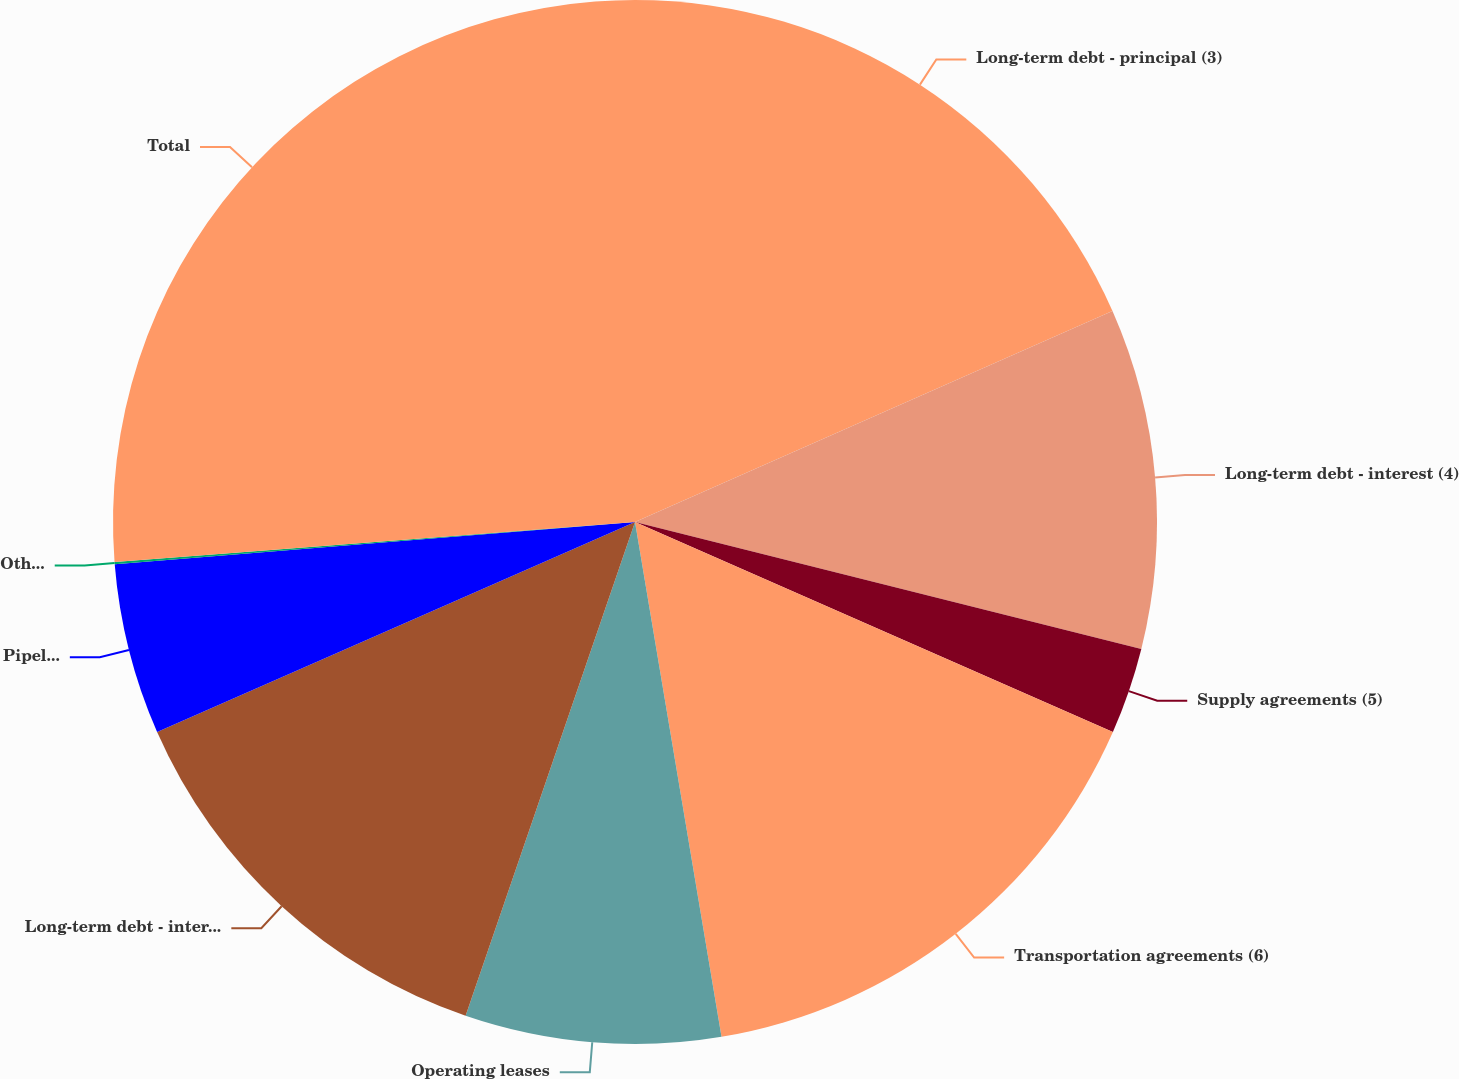<chart> <loc_0><loc_0><loc_500><loc_500><pie_chart><fcel>Long-term debt - principal (3)<fcel>Long-term debt - interest (4)<fcel>Supply agreements (5)<fcel>Transportation agreements (6)<fcel>Operating leases<fcel>Long-term debt - interest (8)<fcel>Pipeline operating and right<fcel>Other agreements<fcel>Total<nl><fcel>18.38%<fcel>10.53%<fcel>2.68%<fcel>15.76%<fcel>7.91%<fcel>13.15%<fcel>5.3%<fcel>0.07%<fcel>26.22%<nl></chart> 